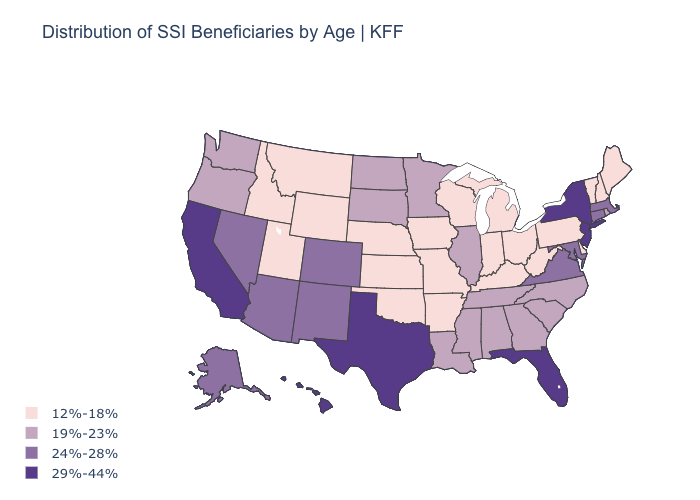Does Tennessee have the highest value in the USA?
Be succinct. No. How many symbols are there in the legend?
Answer briefly. 4. Name the states that have a value in the range 29%-44%?
Concise answer only. California, Florida, Hawaii, New Jersey, New York, Texas. Does New Hampshire have a lower value than New Mexico?
Be succinct. Yes. Is the legend a continuous bar?
Keep it brief. No. Does the first symbol in the legend represent the smallest category?
Write a very short answer. Yes. What is the lowest value in the Northeast?
Be succinct. 12%-18%. Does North Carolina have the same value as Oregon?
Write a very short answer. Yes. Does Wisconsin have the highest value in the MidWest?
Quick response, please. No. Name the states that have a value in the range 24%-28%?
Answer briefly. Alaska, Arizona, Colorado, Connecticut, Maryland, Massachusetts, Nevada, New Mexico, Virginia. Which states have the lowest value in the USA?
Keep it brief. Arkansas, Delaware, Idaho, Indiana, Iowa, Kansas, Kentucky, Maine, Michigan, Missouri, Montana, Nebraska, New Hampshire, Ohio, Oklahoma, Pennsylvania, Utah, Vermont, West Virginia, Wisconsin, Wyoming. Among the states that border Georgia , does Florida have the highest value?
Write a very short answer. Yes. What is the value of Oklahoma?
Write a very short answer. 12%-18%. Name the states that have a value in the range 29%-44%?
Write a very short answer. California, Florida, Hawaii, New Jersey, New York, Texas. Does the first symbol in the legend represent the smallest category?
Answer briefly. Yes. 